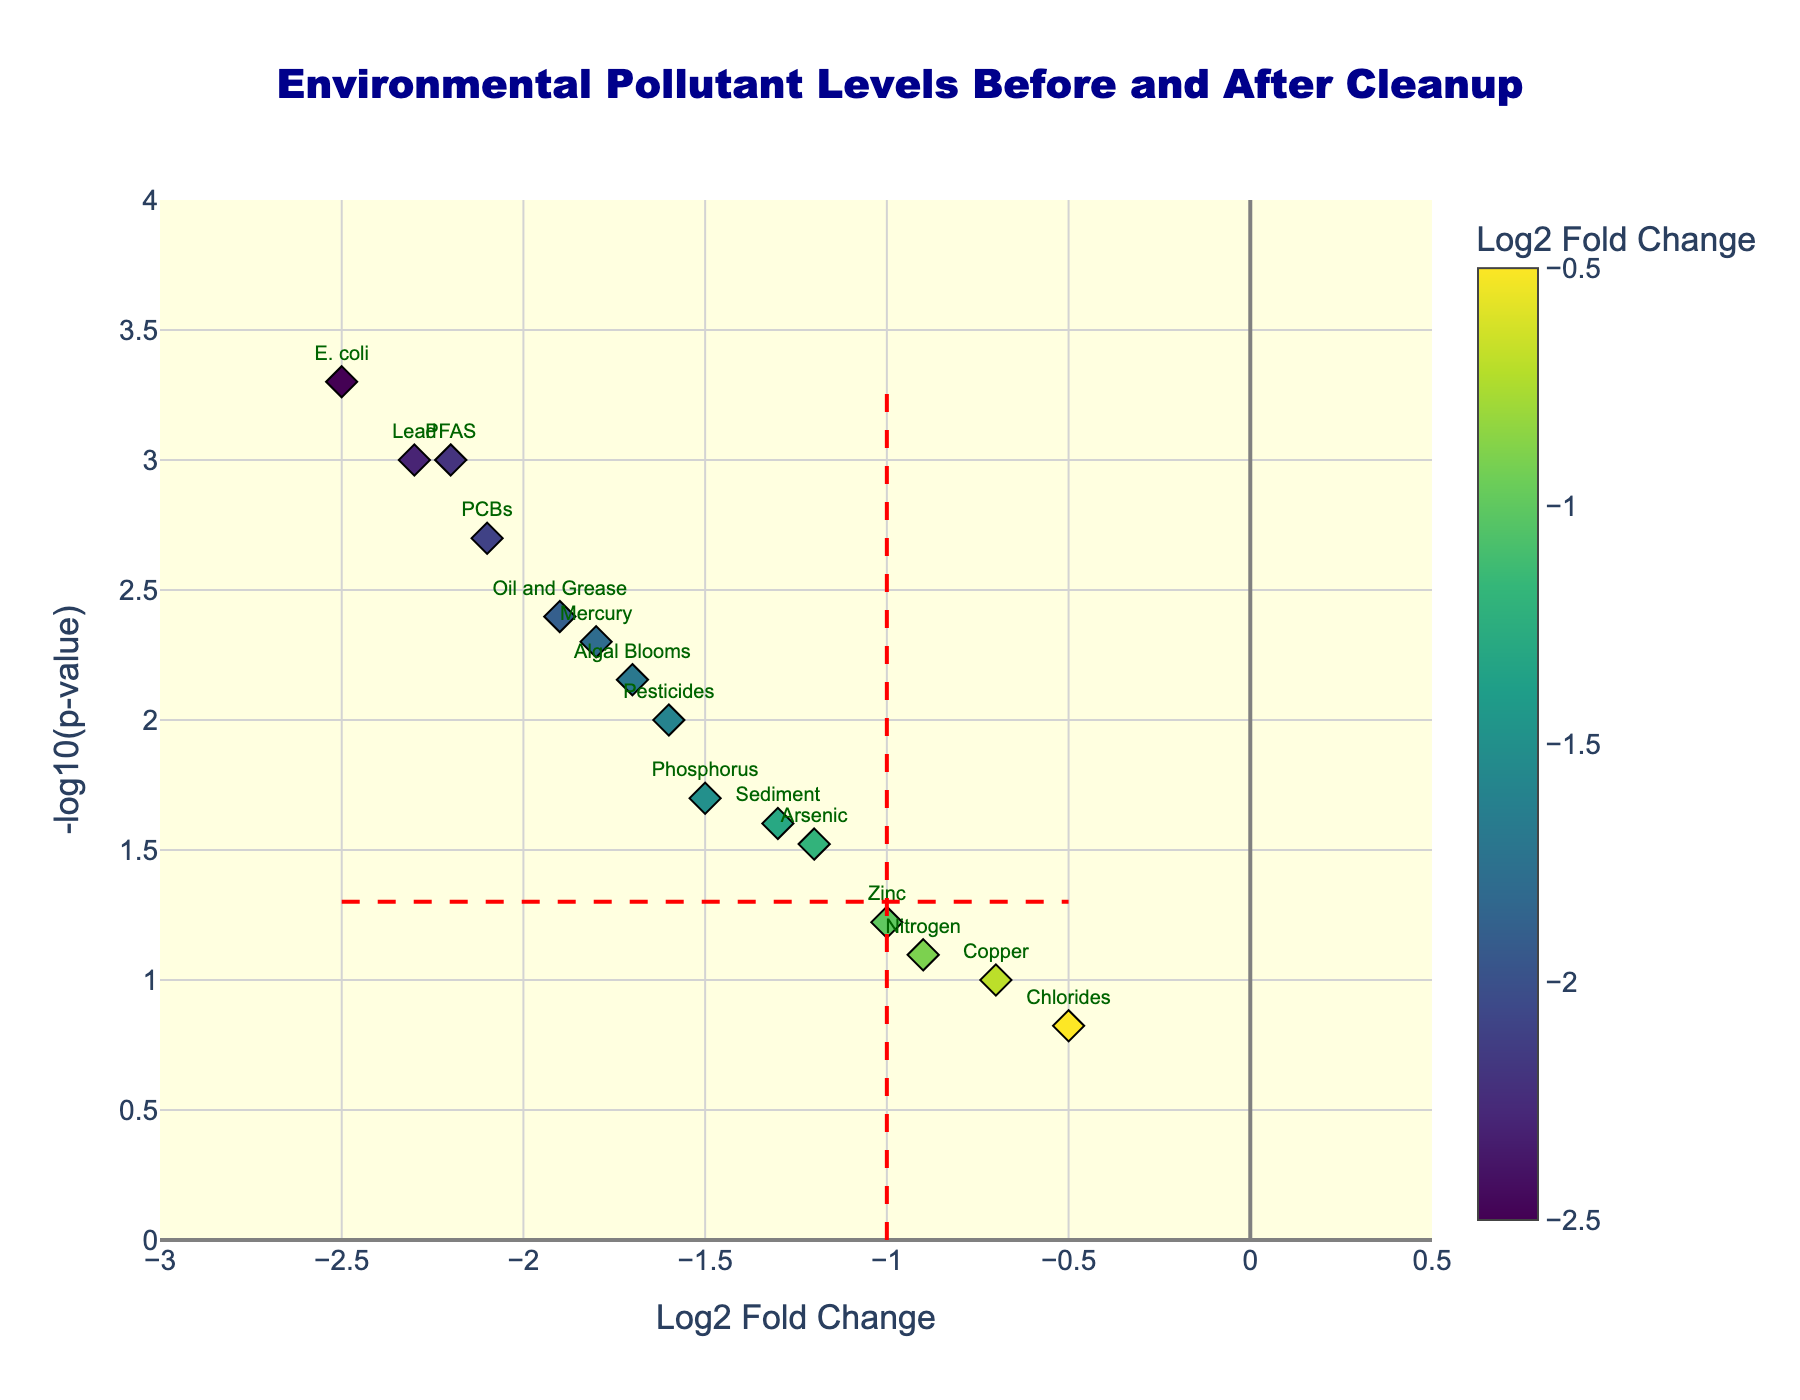What's the title of the figure? The title is usually prominently displayed at the top of the figure, often in larger and bolder font. In this case, it is located there just like in most standard plots.
Answer: Environmental Pollutant Levels Before and After Cleanup How many pollutants are represented in the plot? By counting the data points or the labels for the pollutants displayed in the plot, we can determine the total number of pollutants.
Answer: 15 What does the x-axis represent? The label on the x-axis provides information about what is being plotted along this axis. Here it indicates the change in pollutant levels following the cleanup efforts.
Answer: Log2 Fold Change Which pollutant has the lowest p-value? To find the pollutant with the lowest p-value, we need to look at the y-axis values because it represents -log10(p-value). The higher the y-value, the lower the original p-value, since this transformation inversely scales the original p-value. E. coli is highest vertically.
Answer: E. coli Which pollutants show a significant decrease, considering both log2 fold change and p-value? We need to look for pollutants with a log2 fold change less than -1 and a p-value less than 0.05. This will be in the lower left quadrant of the plot.
Answer: Lead, Mercury, PCBs, E. coli, PFAS, Oil and Grease How is the p-value significance threshold represented in the plot? Significant p-values are often visually indicated in plots. In this plot, it's by a horizontal red dashed line at y = -log10(0.05).
Answer: A horizontal red dashed line What is the log2 fold change of Arsenic? The log2 fold change values can be found on the x-axis. You can match the Arsenic label to its position on the x-axis.
Answer: -1.2 Which pollutant has the greatest absolute change in levels post-cleanup? To answer this, identify the pollutant farthest from zero on the x-axis. E. coli is most leftward, representing the greatest absolute change.
Answer: E. coli Are there any pollutants that have a non-significant change? Non-significant changes are those with p-values greater than 0.05, which would be below the horizontal red dashed line.
Answer: Nitrogen, Copper, Chlorides, Zinc 